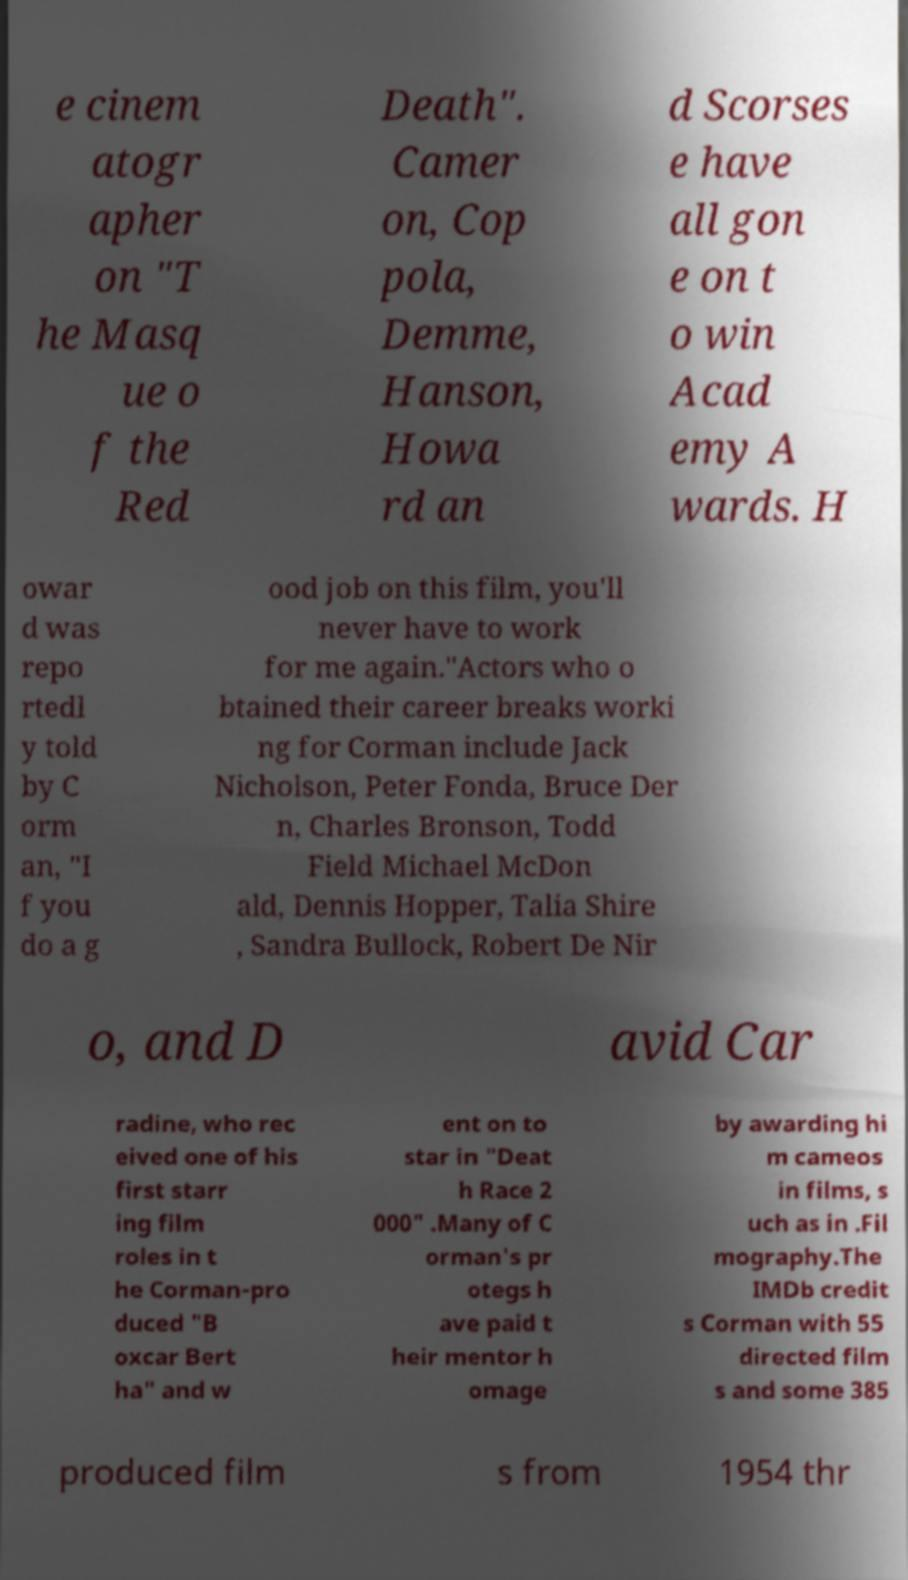There's text embedded in this image that I need extracted. Can you transcribe it verbatim? e cinem atogr apher on "T he Masq ue o f the Red Death". Camer on, Cop pola, Demme, Hanson, Howa rd an d Scorses e have all gon e on t o win Acad emy A wards. H owar d was repo rtedl y told by C orm an, "I f you do a g ood job on this film, you'll never have to work for me again."Actors who o btained their career breaks worki ng for Corman include Jack Nicholson, Peter Fonda, Bruce Der n, Charles Bronson, Todd Field Michael McDon ald, Dennis Hopper, Talia Shire , Sandra Bullock, Robert De Nir o, and D avid Car radine, who rec eived one of his first starr ing film roles in t he Corman-pro duced "B oxcar Bert ha" and w ent on to star in "Deat h Race 2 000" .Many of C orman's pr otegs h ave paid t heir mentor h omage by awarding hi m cameos in films, s uch as in .Fil mography.The IMDb credit s Corman with 55 directed film s and some 385 produced film s from 1954 thr 